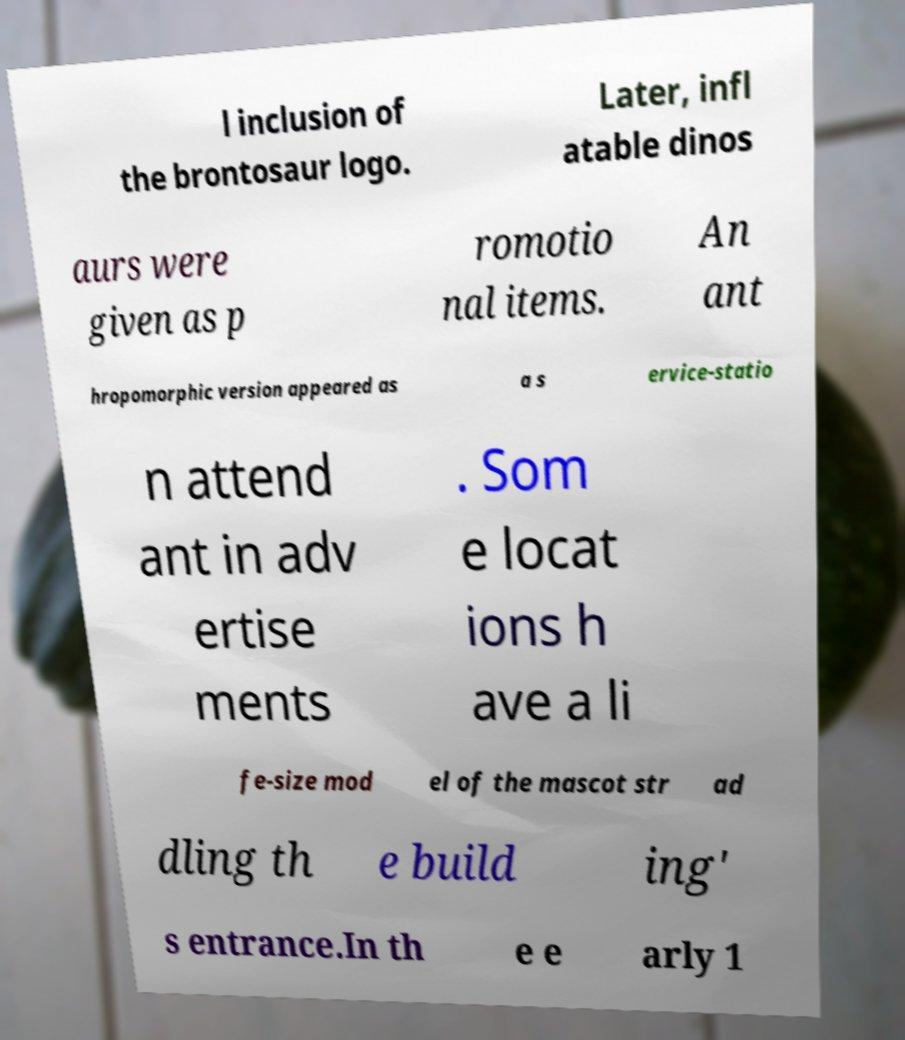I need the written content from this picture converted into text. Can you do that? l inclusion of the brontosaur logo. Later, infl atable dinos aurs were given as p romotio nal items. An ant hropomorphic version appeared as a s ervice-statio n attend ant in adv ertise ments . Som e locat ions h ave a li fe-size mod el of the mascot str ad dling th e build ing' s entrance.In th e e arly 1 